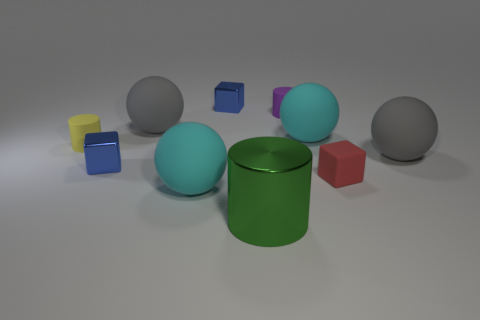Is there a matte thing behind the tiny purple matte cylinder to the right of the tiny yellow cylinder?
Ensure brevity in your answer.  No. What number of objects are large gray balls or small cyan cylinders?
Give a very brief answer. 2. There is a cylinder that is left of the large matte sphere that is to the left of the large rubber sphere in front of the tiny rubber cube; what is its color?
Offer a very short reply. Yellow. Are there any other things of the same color as the big metal object?
Offer a terse response. No. Is the size of the matte cube the same as the metal cylinder?
Give a very brief answer. No. How many things are either rubber things in front of the small purple cylinder or large gray objects to the left of the large green cylinder?
Your response must be concise. 6. The small cube that is behind the cylinder right of the big green shiny thing is made of what material?
Offer a terse response. Metal. What number of other objects are the same material as the tiny yellow cylinder?
Provide a succinct answer. 6. Does the big metal object have the same shape as the small red rubber thing?
Provide a succinct answer. No. What size is the green cylinder that is in front of the red rubber object?
Provide a succinct answer. Large. 